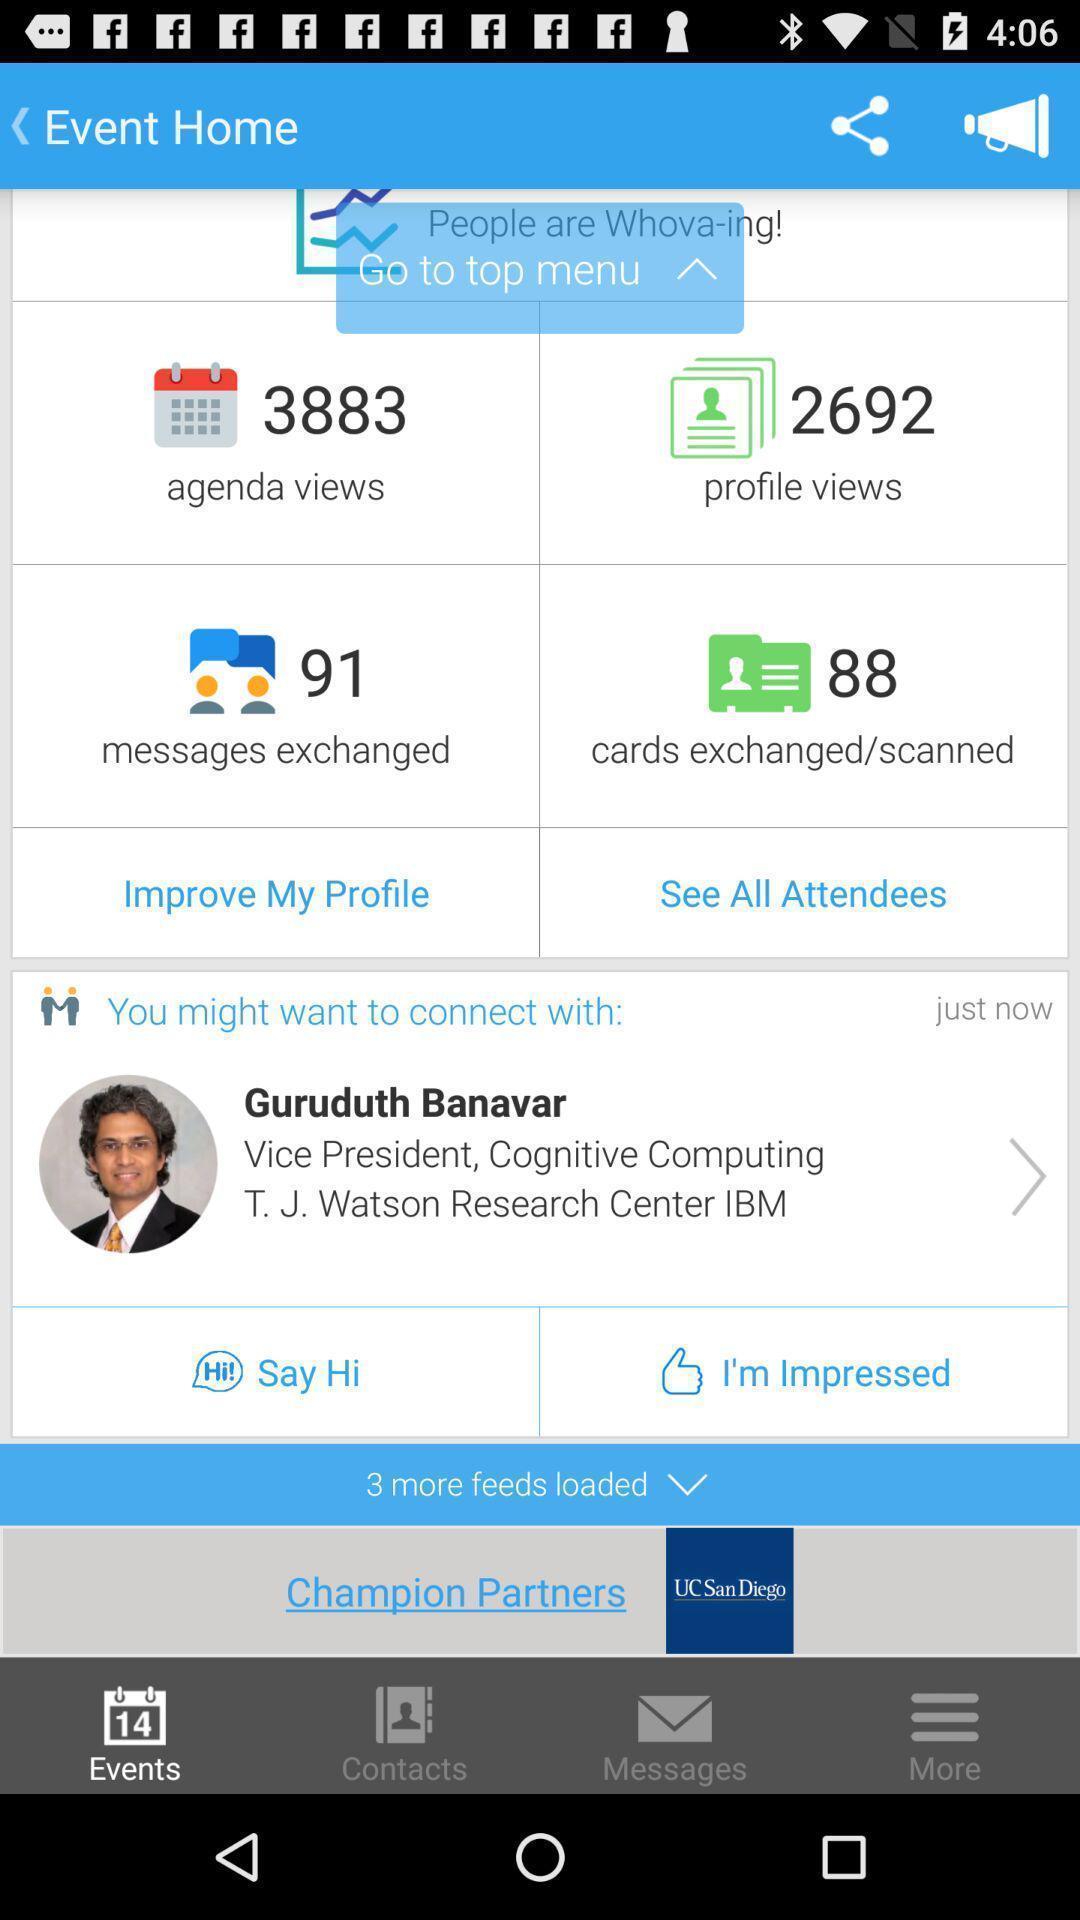Tell me about the visual elements in this screen capture. Page showing events. 